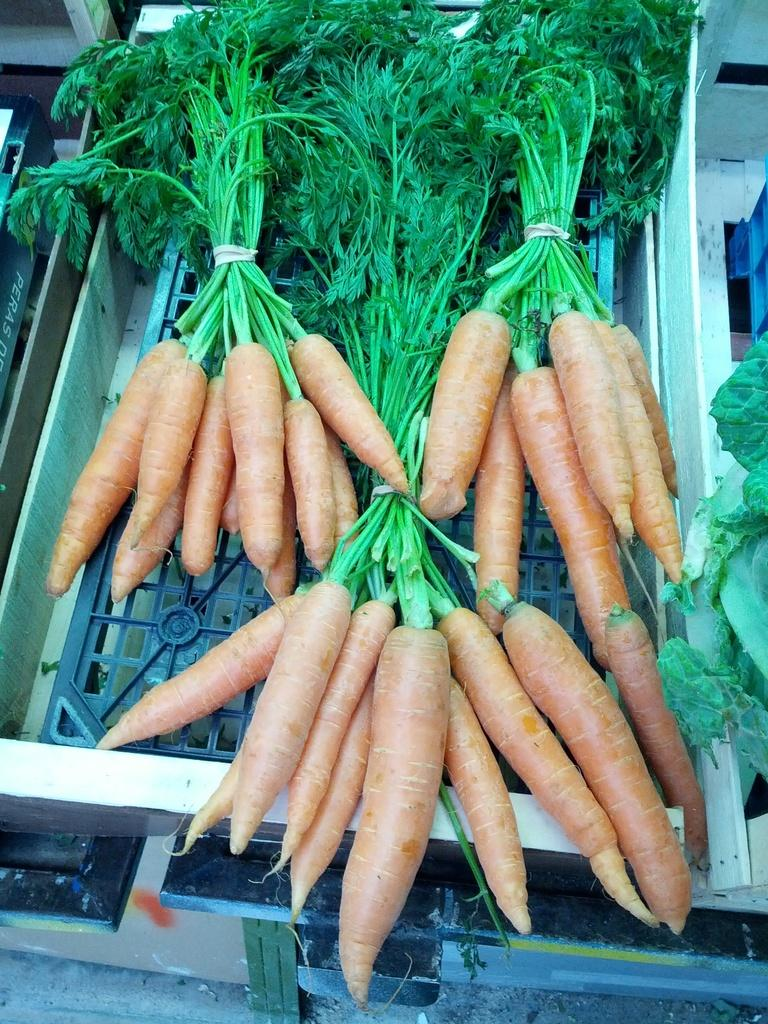What type of food can be seen in the image? There are carrots in the image, which are a type of vegetable. What category of food do the carrots belong to? The carrots and vegetables in the image belong to the vegetable category. How are the carrots and vegetables arranged in the image? The carrots and vegetables are on a metal grill plate. How many girls are sitting on the chair in the image? There are no girls or chairs present in the image; it features carrots and vegetables on a metal grill plate. 